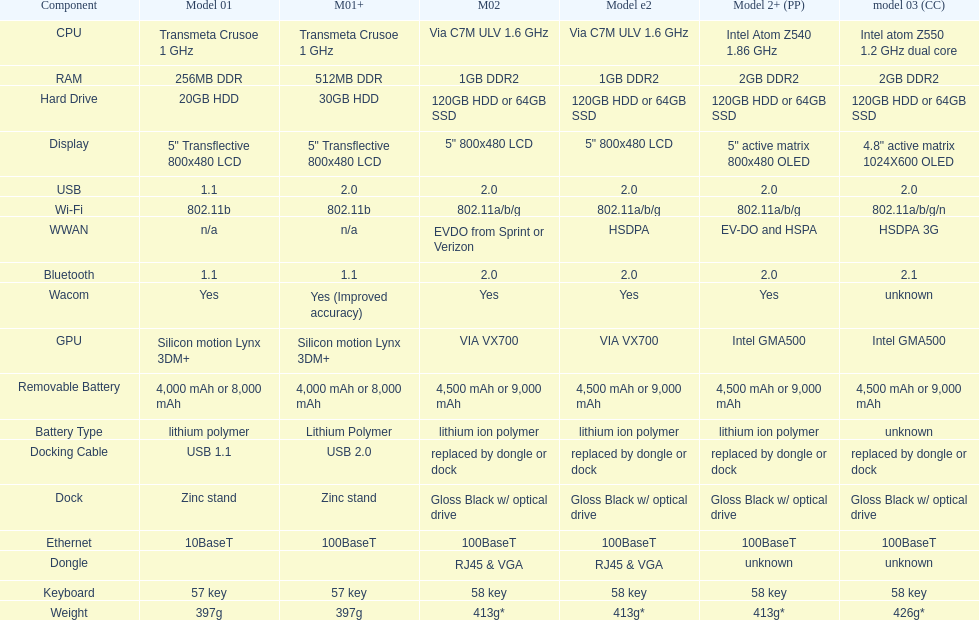Which model provides a larger hard drive: model 01 or model 02? Model 02. 